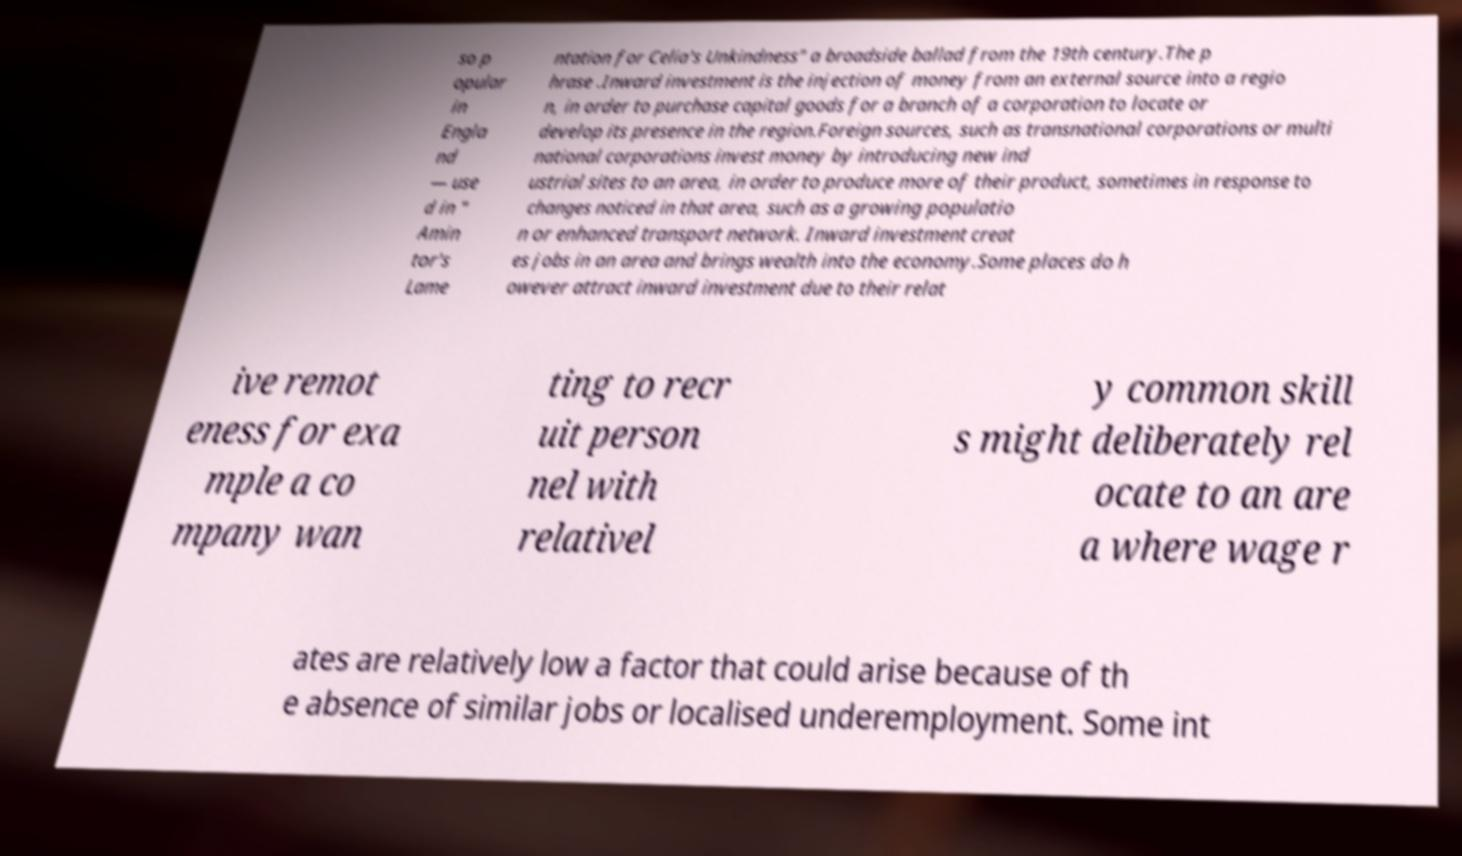What messages or text are displayed in this image? I need them in a readable, typed format. so p opular in Engla nd — use d in " Amin tor's Lame ntation for Celia's Unkindness" a broadside ballad from the 19th century.The p hrase .Inward investment is the injection of money from an external source into a regio n, in order to purchase capital goods for a branch of a corporation to locate or develop its presence in the region.Foreign sources, such as transnational corporations or multi national corporations invest money by introducing new ind ustrial sites to an area, in order to produce more of their product, sometimes in response to changes noticed in that area, such as a growing populatio n or enhanced transport network. Inward investment creat es jobs in an area and brings wealth into the economy.Some places do h owever attract inward investment due to their relat ive remot eness for exa mple a co mpany wan ting to recr uit person nel with relativel y common skill s might deliberately rel ocate to an are a where wage r ates are relatively low a factor that could arise because of th e absence of similar jobs or localised underemployment. Some int 